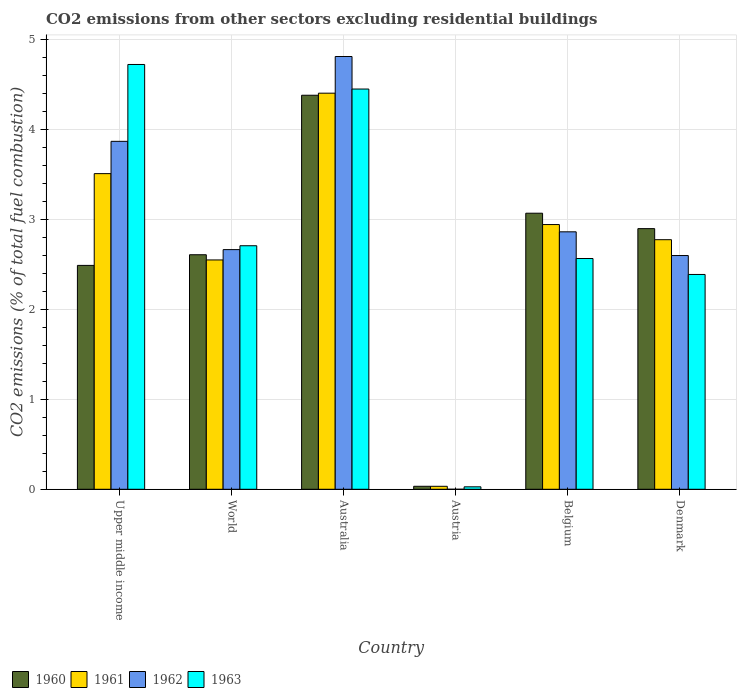How many different coloured bars are there?
Your answer should be very brief. 4. How many groups of bars are there?
Keep it short and to the point. 6. How many bars are there on the 1st tick from the left?
Keep it short and to the point. 4. In how many cases, is the number of bars for a given country not equal to the number of legend labels?
Offer a terse response. 1. What is the total CO2 emitted in 1963 in Austria?
Ensure brevity in your answer.  0.03. Across all countries, what is the maximum total CO2 emitted in 1961?
Make the answer very short. 4.41. Across all countries, what is the minimum total CO2 emitted in 1963?
Your response must be concise. 0.03. In which country was the total CO2 emitted in 1960 maximum?
Make the answer very short. Australia. What is the total total CO2 emitted in 1962 in the graph?
Make the answer very short. 16.82. What is the difference between the total CO2 emitted in 1961 in Belgium and that in World?
Offer a terse response. 0.39. What is the difference between the total CO2 emitted in 1962 in Australia and the total CO2 emitted in 1961 in Upper middle income?
Give a very brief answer. 1.3. What is the average total CO2 emitted in 1963 per country?
Your answer should be very brief. 2.81. What is the difference between the total CO2 emitted of/in 1961 and total CO2 emitted of/in 1962 in Upper middle income?
Your answer should be very brief. -0.36. In how many countries, is the total CO2 emitted in 1960 greater than 4.4?
Your answer should be very brief. 0. What is the ratio of the total CO2 emitted in 1963 in Australia to that in Belgium?
Offer a very short reply. 1.73. Is the difference between the total CO2 emitted in 1961 in Belgium and Denmark greater than the difference between the total CO2 emitted in 1962 in Belgium and Denmark?
Offer a very short reply. No. What is the difference between the highest and the second highest total CO2 emitted in 1961?
Your answer should be very brief. -0.57. What is the difference between the highest and the lowest total CO2 emitted in 1962?
Make the answer very short. 4.82. Is it the case that in every country, the sum of the total CO2 emitted in 1960 and total CO2 emitted in 1962 is greater than the total CO2 emitted in 1963?
Give a very brief answer. Yes. Does the graph contain any zero values?
Keep it short and to the point. Yes. Does the graph contain grids?
Your answer should be very brief. Yes. How many legend labels are there?
Provide a succinct answer. 4. How are the legend labels stacked?
Your response must be concise. Horizontal. What is the title of the graph?
Provide a short and direct response. CO2 emissions from other sectors excluding residential buildings. Does "1992" appear as one of the legend labels in the graph?
Your answer should be very brief. No. What is the label or title of the Y-axis?
Keep it short and to the point. CO2 emissions (% of total fuel combustion). What is the CO2 emissions (% of total fuel combustion) of 1960 in Upper middle income?
Give a very brief answer. 2.49. What is the CO2 emissions (% of total fuel combustion) in 1961 in Upper middle income?
Offer a very short reply. 3.51. What is the CO2 emissions (% of total fuel combustion) in 1962 in Upper middle income?
Ensure brevity in your answer.  3.87. What is the CO2 emissions (% of total fuel combustion) in 1963 in Upper middle income?
Offer a terse response. 4.73. What is the CO2 emissions (% of total fuel combustion) in 1960 in World?
Offer a terse response. 2.61. What is the CO2 emissions (% of total fuel combustion) in 1961 in World?
Offer a very short reply. 2.55. What is the CO2 emissions (% of total fuel combustion) in 1962 in World?
Offer a very short reply. 2.67. What is the CO2 emissions (% of total fuel combustion) in 1963 in World?
Provide a short and direct response. 2.71. What is the CO2 emissions (% of total fuel combustion) of 1960 in Australia?
Provide a short and direct response. 4.38. What is the CO2 emissions (% of total fuel combustion) of 1961 in Australia?
Ensure brevity in your answer.  4.41. What is the CO2 emissions (% of total fuel combustion) of 1962 in Australia?
Offer a very short reply. 4.82. What is the CO2 emissions (% of total fuel combustion) of 1963 in Australia?
Make the answer very short. 4.45. What is the CO2 emissions (% of total fuel combustion) in 1960 in Austria?
Offer a terse response. 0.03. What is the CO2 emissions (% of total fuel combustion) of 1961 in Austria?
Ensure brevity in your answer.  0.03. What is the CO2 emissions (% of total fuel combustion) of 1962 in Austria?
Keep it short and to the point. 0. What is the CO2 emissions (% of total fuel combustion) of 1963 in Austria?
Make the answer very short. 0.03. What is the CO2 emissions (% of total fuel combustion) of 1960 in Belgium?
Your answer should be very brief. 3.07. What is the CO2 emissions (% of total fuel combustion) in 1961 in Belgium?
Make the answer very short. 2.95. What is the CO2 emissions (% of total fuel combustion) in 1962 in Belgium?
Provide a succinct answer. 2.86. What is the CO2 emissions (% of total fuel combustion) of 1963 in Belgium?
Your answer should be compact. 2.57. What is the CO2 emissions (% of total fuel combustion) of 1960 in Denmark?
Provide a short and direct response. 2.9. What is the CO2 emissions (% of total fuel combustion) of 1961 in Denmark?
Ensure brevity in your answer.  2.78. What is the CO2 emissions (% of total fuel combustion) of 1962 in Denmark?
Provide a succinct answer. 2.6. What is the CO2 emissions (% of total fuel combustion) in 1963 in Denmark?
Ensure brevity in your answer.  2.39. Across all countries, what is the maximum CO2 emissions (% of total fuel combustion) of 1960?
Offer a very short reply. 4.38. Across all countries, what is the maximum CO2 emissions (% of total fuel combustion) of 1961?
Offer a very short reply. 4.41. Across all countries, what is the maximum CO2 emissions (% of total fuel combustion) in 1962?
Keep it short and to the point. 4.82. Across all countries, what is the maximum CO2 emissions (% of total fuel combustion) in 1963?
Give a very brief answer. 4.73. Across all countries, what is the minimum CO2 emissions (% of total fuel combustion) in 1960?
Offer a terse response. 0.03. Across all countries, what is the minimum CO2 emissions (% of total fuel combustion) of 1961?
Provide a succinct answer. 0.03. Across all countries, what is the minimum CO2 emissions (% of total fuel combustion) of 1963?
Make the answer very short. 0.03. What is the total CO2 emissions (% of total fuel combustion) of 1960 in the graph?
Provide a succinct answer. 15.49. What is the total CO2 emissions (% of total fuel combustion) in 1961 in the graph?
Your answer should be very brief. 16.23. What is the total CO2 emissions (% of total fuel combustion) of 1962 in the graph?
Offer a very short reply. 16.82. What is the total CO2 emissions (% of total fuel combustion) in 1963 in the graph?
Provide a succinct answer. 16.87. What is the difference between the CO2 emissions (% of total fuel combustion) of 1960 in Upper middle income and that in World?
Your answer should be compact. -0.12. What is the difference between the CO2 emissions (% of total fuel combustion) in 1961 in Upper middle income and that in World?
Ensure brevity in your answer.  0.96. What is the difference between the CO2 emissions (% of total fuel combustion) in 1962 in Upper middle income and that in World?
Your answer should be compact. 1.2. What is the difference between the CO2 emissions (% of total fuel combustion) in 1963 in Upper middle income and that in World?
Offer a terse response. 2.02. What is the difference between the CO2 emissions (% of total fuel combustion) of 1960 in Upper middle income and that in Australia?
Give a very brief answer. -1.89. What is the difference between the CO2 emissions (% of total fuel combustion) of 1961 in Upper middle income and that in Australia?
Provide a succinct answer. -0.9. What is the difference between the CO2 emissions (% of total fuel combustion) in 1962 in Upper middle income and that in Australia?
Offer a terse response. -0.94. What is the difference between the CO2 emissions (% of total fuel combustion) of 1963 in Upper middle income and that in Australia?
Provide a short and direct response. 0.27. What is the difference between the CO2 emissions (% of total fuel combustion) in 1960 in Upper middle income and that in Austria?
Your answer should be compact. 2.46. What is the difference between the CO2 emissions (% of total fuel combustion) in 1961 in Upper middle income and that in Austria?
Keep it short and to the point. 3.48. What is the difference between the CO2 emissions (% of total fuel combustion) in 1963 in Upper middle income and that in Austria?
Your response must be concise. 4.7. What is the difference between the CO2 emissions (% of total fuel combustion) in 1960 in Upper middle income and that in Belgium?
Your answer should be very brief. -0.58. What is the difference between the CO2 emissions (% of total fuel combustion) of 1961 in Upper middle income and that in Belgium?
Give a very brief answer. 0.57. What is the difference between the CO2 emissions (% of total fuel combustion) of 1962 in Upper middle income and that in Belgium?
Ensure brevity in your answer.  1.01. What is the difference between the CO2 emissions (% of total fuel combustion) of 1963 in Upper middle income and that in Belgium?
Provide a succinct answer. 2.16. What is the difference between the CO2 emissions (% of total fuel combustion) of 1960 in Upper middle income and that in Denmark?
Your response must be concise. -0.41. What is the difference between the CO2 emissions (% of total fuel combustion) in 1961 in Upper middle income and that in Denmark?
Keep it short and to the point. 0.74. What is the difference between the CO2 emissions (% of total fuel combustion) of 1962 in Upper middle income and that in Denmark?
Your answer should be very brief. 1.27. What is the difference between the CO2 emissions (% of total fuel combustion) of 1963 in Upper middle income and that in Denmark?
Provide a short and direct response. 2.34. What is the difference between the CO2 emissions (% of total fuel combustion) in 1960 in World and that in Australia?
Your answer should be compact. -1.77. What is the difference between the CO2 emissions (% of total fuel combustion) in 1961 in World and that in Australia?
Offer a very short reply. -1.86. What is the difference between the CO2 emissions (% of total fuel combustion) of 1962 in World and that in Australia?
Offer a very short reply. -2.15. What is the difference between the CO2 emissions (% of total fuel combustion) in 1963 in World and that in Australia?
Give a very brief answer. -1.74. What is the difference between the CO2 emissions (% of total fuel combustion) in 1960 in World and that in Austria?
Provide a short and direct response. 2.58. What is the difference between the CO2 emissions (% of total fuel combustion) of 1961 in World and that in Austria?
Make the answer very short. 2.52. What is the difference between the CO2 emissions (% of total fuel combustion) of 1963 in World and that in Austria?
Ensure brevity in your answer.  2.68. What is the difference between the CO2 emissions (% of total fuel combustion) of 1960 in World and that in Belgium?
Offer a terse response. -0.46. What is the difference between the CO2 emissions (% of total fuel combustion) of 1961 in World and that in Belgium?
Offer a terse response. -0.39. What is the difference between the CO2 emissions (% of total fuel combustion) of 1962 in World and that in Belgium?
Offer a very short reply. -0.2. What is the difference between the CO2 emissions (% of total fuel combustion) in 1963 in World and that in Belgium?
Provide a short and direct response. 0.14. What is the difference between the CO2 emissions (% of total fuel combustion) of 1960 in World and that in Denmark?
Your answer should be compact. -0.29. What is the difference between the CO2 emissions (% of total fuel combustion) in 1961 in World and that in Denmark?
Keep it short and to the point. -0.23. What is the difference between the CO2 emissions (% of total fuel combustion) of 1962 in World and that in Denmark?
Give a very brief answer. 0.07. What is the difference between the CO2 emissions (% of total fuel combustion) of 1963 in World and that in Denmark?
Ensure brevity in your answer.  0.32. What is the difference between the CO2 emissions (% of total fuel combustion) of 1960 in Australia and that in Austria?
Make the answer very short. 4.35. What is the difference between the CO2 emissions (% of total fuel combustion) of 1961 in Australia and that in Austria?
Your answer should be very brief. 4.37. What is the difference between the CO2 emissions (% of total fuel combustion) in 1963 in Australia and that in Austria?
Give a very brief answer. 4.43. What is the difference between the CO2 emissions (% of total fuel combustion) in 1960 in Australia and that in Belgium?
Provide a short and direct response. 1.31. What is the difference between the CO2 emissions (% of total fuel combustion) in 1961 in Australia and that in Belgium?
Provide a short and direct response. 1.46. What is the difference between the CO2 emissions (% of total fuel combustion) of 1962 in Australia and that in Belgium?
Give a very brief answer. 1.95. What is the difference between the CO2 emissions (% of total fuel combustion) of 1963 in Australia and that in Belgium?
Ensure brevity in your answer.  1.89. What is the difference between the CO2 emissions (% of total fuel combustion) in 1960 in Australia and that in Denmark?
Your response must be concise. 1.48. What is the difference between the CO2 emissions (% of total fuel combustion) in 1961 in Australia and that in Denmark?
Offer a terse response. 1.63. What is the difference between the CO2 emissions (% of total fuel combustion) in 1962 in Australia and that in Denmark?
Offer a terse response. 2.21. What is the difference between the CO2 emissions (% of total fuel combustion) of 1963 in Australia and that in Denmark?
Provide a succinct answer. 2.06. What is the difference between the CO2 emissions (% of total fuel combustion) in 1960 in Austria and that in Belgium?
Provide a short and direct response. -3.04. What is the difference between the CO2 emissions (% of total fuel combustion) of 1961 in Austria and that in Belgium?
Offer a very short reply. -2.91. What is the difference between the CO2 emissions (% of total fuel combustion) in 1963 in Austria and that in Belgium?
Make the answer very short. -2.54. What is the difference between the CO2 emissions (% of total fuel combustion) of 1960 in Austria and that in Denmark?
Your answer should be compact. -2.87. What is the difference between the CO2 emissions (% of total fuel combustion) in 1961 in Austria and that in Denmark?
Your answer should be very brief. -2.74. What is the difference between the CO2 emissions (% of total fuel combustion) in 1963 in Austria and that in Denmark?
Give a very brief answer. -2.36. What is the difference between the CO2 emissions (% of total fuel combustion) of 1960 in Belgium and that in Denmark?
Your answer should be very brief. 0.17. What is the difference between the CO2 emissions (% of total fuel combustion) of 1961 in Belgium and that in Denmark?
Your response must be concise. 0.17. What is the difference between the CO2 emissions (% of total fuel combustion) in 1962 in Belgium and that in Denmark?
Your answer should be very brief. 0.26. What is the difference between the CO2 emissions (% of total fuel combustion) in 1963 in Belgium and that in Denmark?
Provide a short and direct response. 0.18. What is the difference between the CO2 emissions (% of total fuel combustion) in 1960 in Upper middle income and the CO2 emissions (% of total fuel combustion) in 1961 in World?
Your response must be concise. -0.06. What is the difference between the CO2 emissions (% of total fuel combustion) of 1960 in Upper middle income and the CO2 emissions (% of total fuel combustion) of 1962 in World?
Give a very brief answer. -0.18. What is the difference between the CO2 emissions (% of total fuel combustion) of 1960 in Upper middle income and the CO2 emissions (% of total fuel combustion) of 1963 in World?
Make the answer very short. -0.22. What is the difference between the CO2 emissions (% of total fuel combustion) in 1961 in Upper middle income and the CO2 emissions (% of total fuel combustion) in 1962 in World?
Make the answer very short. 0.85. What is the difference between the CO2 emissions (% of total fuel combustion) of 1961 in Upper middle income and the CO2 emissions (% of total fuel combustion) of 1963 in World?
Ensure brevity in your answer.  0.8. What is the difference between the CO2 emissions (% of total fuel combustion) of 1962 in Upper middle income and the CO2 emissions (% of total fuel combustion) of 1963 in World?
Ensure brevity in your answer.  1.16. What is the difference between the CO2 emissions (% of total fuel combustion) in 1960 in Upper middle income and the CO2 emissions (% of total fuel combustion) in 1961 in Australia?
Your answer should be very brief. -1.92. What is the difference between the CO2 emissions (% of total fuel combustion) in 1960 in Upper middle income and the CO2 emissions (% of total fuel combustion) in 1962 in Australia?
Ensure brevity in your answer.  -2.32. What is the difference between the CO2 emissions (% of total fuel combustion) in 1960 in Upper middle income and the CO2 emissions (% of total fuel combustion) in 1963 in Australia?
Provide a succinct answer. -1.96. What is the difference between the CO2 emissions (% of total fuel combustion) of 1961 in Upper middle income and the CO2 emissions (% of total fuel combustion) of 1962 in Australia?
Provide a short and direct response. -1.3. What is the difference between the CO2 emissions (% of total fuel combustion) in 1961 in Upper middle income and the CO2 emissions (% of total fuel combustion) in 1963 in Australia?
Offer a terse response. -0.94. What is the difference between the CO2 emissions (% of total fuel combustion) in 1962 in Upper middle income and the CO2 emissions (% of total fuel combustion) in 1963 in Australia?
Make the answer very short. -0.58. What is the difference between the CO2 emissions (% of total fuel combustion) of 1960 in Upper middle income and the CO2 emissions (% of total fuel combustion) of 1961 in Austria?
Provide a succinct answer. 2.46. What is the difference between the CO2 emissions (% of total fuel combustion) of 1960 in Upper middle income and the CO2 emissions (% of total fuel combustion) of 1963 in Austria?
Your answer should be compact. 2.46. What is the difference between the CO2 emissions (% of total fuel combustion) in 1961 in Upper middle income and the CO2 emissions (% of total fuel combustion) in 1963 in Austria?
Provide a short and direct response. 3.48. What is the difference between the CO2 emissions (% of total fuel combustion) in 1962 in Upper middle income and the CO2 emissions (% of total fuel combustion) in 1963 in Austria?
Your response must be concise. 3.84. What is the difference between the CO2 emissions (% of total fuel combustion) of 1960 in Upper middle income and the CO2 emissions (% of total fuel combustion) of 1961 in Belgium?
Keep it short and to the point. -0.45. What is the difference between the CO2 emissions (% of total fuel combustion) of 1960 in Upper middle income and the CO2 emissions (% of total fuel combustion) of 1962 in Belgium?
Your answer should be very brief. -0.37. What is the difference between the CO2 emissions (% of total fuel combustion) in 1960 in Upper middle income and the CO2 emissions (% of total fuel combustion) in 1963 in Belgium?
Ensure brevity in your answer.  -0.08. What is the difference between the CO2 emissions (% of total fuel combustion) in 1961 in Upper middle income and the CO2 emissions (% of total fuel combustion) in 1962 in Belgium?
Make the answer very short. 0.65. What is the difference between the CO2 emissions (% of total fuel combustion) of 1962 in Upper middle income and the CO2 emissions (% of total fuel combustion) of 1963 in Belgium?
Your answer should be compact. 1.3. What is the difference between the CO2 emissions (% of total fuel combustion) in 1960 in Upper middle income and the CO2 emissions (% of total fuel combustion) in 1961 in Denmark?
Your answer should be compact. -0.29. What is the difference between the CO2 emissions (% of total fuel combustion) in 1960 in Upper middle income and the CO2 emissions (% of total fuel combustion) in 1962 in Denmark?
Make the answer very short. -0.11. What is the difference between the CO2 emissions (% of total fuel combustion) of 1960 in Upper middle income and the CO2 emissions (% of total fuel combustion) of 1963 in Denmark?
Give a very brief answer. 0.1. What is the difference between the CO2 emissions (% of total fuel combustion) of 1961 in Upper middle income and the CO2 emissions (% of total fuel combustion) of 1962 in Denmark?
Offer a terse response. 0.91. What is the difference between the CO2 emissions (% of total fuel combustion) of 1961 in Upper middle income and the CO2 emissions (% of total fuel combustion) of 1963 in Denmark?
Give a very brief answer. 1.12. What is the difference between the CO2 emissions (% of total fuel combustion) in 1962 in Upper middle income and the CO2 emissions (% of total fuel combustion) in 1963 in Denmark?
Keep it short and to the point. 1.48. What is the difference between the CO2 emissions (% of total fuel combustion) in 1960 in World and the CO2 emissions (% of total fuel combustion) in 1961 in Australia?
Make the answer very short. -1.8. What is the difference between the CO2 emissions (% of total fuel combustion) in 1960 in World and the CO2 emissions (% of total fuel combustion) in 1962 in Australia?
Make the answer very short. -2.21. What is the difference between the CO2 emissions (% of total fuel combustion) in 1960 in World and the CO2 emissions (% of total fuel combustion) in 1963 in Australia?
Offer a very short reply. -1.84. What is the difference between the CO2 emissions (% of total fuel combustion) of 1961 in World and the CO2 emissions (% of total fuel combustion) of 1962 in Australia?
Make the answer very short. -2.26. What is the difference between the CO2 emissions (% of total fuel combustion) of 1961 in World and the CO2 emissions (% of total fuel combustion) of 1963 in Australia?
Give a very brief answer. -1.9. What is the difference between the CO2 emissions (% of total fuel combustion) in 1962 in World and the CO2 emissions (% of total fuel combustion) in 1963 in Australia?
Provide a short and direct response. -1.79. What is the difference between the CO2 emissions (% of total fuel combustion) of 1960 in World and the CO2 emissions (% of total fuel combustion) of 1961 in Austria?
Give a very brief answer. 2.58. What is the difference between the CO2 emissions (% of total fuel combustion) of 1960 in World and the CO2 emissions (% of total fuel combustion) of 1963 in Austria?
Offer a terse response. 2.58. What is the difference between the CO2 emissions (% of total fuel combustion) of 1961 in World and the CO2 emissions (% of total fuel combustion) of 1963 in Austria?
Provide a succinct answer. 2.52. What is the difference between the CO2 emissions (% of total fuel combustion) of 1962 in World and the CO2 emissions (% of total fuel combustion) of 1963 in Austria?
Make the answer very short. 2.64. What is the difference between the CO2 emissions (% of total fuel combustion) of 1960 in World and the CO2 emissions (% of total fuel combustion) of 1961 in Belgium?
Give a very brief answer. -0.34. What is the difference between the CO2 emissions (% of total fuel combustion) in 1960 in World and the CO2 emissions (% of total fuel combustion) in 1962 in Belgium?
Keep it short and to the point. -0.26. What is the difference between the CO2 emissions (% of total fuel combustion) in 1960 in World and the CO2 emissions (% of total fuel combustion) in 1963 in Belgium?
Provide a short and direct response. 0.04. What is the difference between the CO2 emissions (% of total fuel combustion) in 1961 in World and the CO2 emissions (% of total fuel combustion) in 1962 in Belgium?
Give a very brief answer. -0.31. What is the difference between the CO2 emissions (% of total fuel combustion) in 1961 in World and the CO2 emissions (% of total fuel combustion) in 1963 in Belgium?
Your response must be concise. -0.02. What is the difference between the CO2 emissions (% of total fuel combustion) in 1962 in World and the CO2 emissions (% of total fuel combustion) in 1963 in Belgium?
Provide a succinct answer. 0.1. What is the difference between the CO2 emissions (% of total fuel combustion) in 1960 in World and the CO2 emissions (% of total fuel combustion) in 1961 in Denmark?
Your answer should be compact. -0.17. What is the difference between the CO2 emissions (% of total fuel combustion) of 1960 in World and the CO2 emissions (% of total fuel combustion) of 1962 in Denmark?
Your answer should be very brief. 0.01. What is the difference between the CO2 emissions (% of total fuel combustion) in 1960 in World and the CO2 emissions (% of total fuel combustion) in 1963 in Denmark?
Your answer should be very brief. 0.22. What is the difference between the CO2 emissions (% of total fuel combustion) of 1961 in World and the CO2 emissions (% of total fuel combustion) of 1962 in Denmark?
Make the answer very short. -0.05. What is the difference between the CO2 emissions (% of total fuel combustion) in 1961 in World and the CO2 emissions (% of total fuel combustion) in 1963 in Denmark?
Your answer should be compact. 0.16. What is the difference between the CO2 emissions (% of total fuel combustion) of 1962 in World and the CO2 emissions (% of total fuel combustion) of 1963 in Denmark?
Your answer should be compact. 0.28. What is the difference between the CO2 emissions (% of total fuel combustion) of 1960 in Australia and the CO2 emissions (% of total fuel combustion) of 1961 in Austria?
Your response must be concise. 4.35. What is the difference between the CO2 emissions (% of total fuel combustion) in 1960 in Australia and the CO2 emissions (% of total fuel combustion) in 1963 in Austria?
Offer a very short reply. 4.36. What is the difference between the CO2 emissions (% of total fuel combustion) of 1961 in Australia and the CO2 emissions (% of total fuel combustion) of 1963 in Austria?
Make the answer very short. 4.38. What is the difference between the CO2 emissions (% of total fuel combustion) in 1962 in Australia and the CO2 emissions (% of total fuel combustion) in 1963 in Austria?
Offer a terse response. 4.79. What is the difference between the CO2 emissions (% of total fuel combustion) in 1960 in Australia and the CO2 emissions (% of total fuel combustion) in 1961 in Belgium?
Give a very brief answer. 1.44. What is the difference between the CO2 emissions (% of total fuel combustion) of 1960 in Australia and the CO2 emissions (% of total fuel combustion) of 1962 in Belgium?
Your response must be concise. 1.52. What is the difference between the CO2 emissions (% of total fuel combustion) of 1960 in Australia and the CO2 emissions (% of total fuel combustion) of 1963 in Belgium?
Keep it short and to the point. 1.82. What is the difference between the CO2 emissions (% of total fuel combustion) in 1961 in Australia and the CO2 emissions (% of total fuel combustion) in 1962 in Belgium?
Make the answer very short. 1.54. What is the difference between the CO2 emissions (% of total fuel combustion) of 1961 in Australia and the CO2 emissions (% of total fuel combustion) of 1963 in Belgium?
Make the answer very short. 1.84. What is the difference between the CO2 emissions (% of total fuel combustion) in 1962 in Australia and the CO2 emissions (% of total fuel combustion) in 1963 in Belgium?
Provide a succinct answer. 2.25. What is the difference between the CO2 emissions (% of total fuel combustion) of 1960 in Australia and the CO2 emissions (% of total fuel combustion) of 1961 in Denmark?
Your answer should be compact. 1.61. What is the difference between the CO2 emissions (% of total fuel combustion) in 1960 in Australia and the CO2 emissions (% of total fuel combustion) in 1962 in Denmark?
Give a very brief answer. 1.78. What is the difference between the CO2 emissions (% of total fuel combustion) of 1960 in Australia and the CO2 emissions (% of total fuel combustion) of 1963 in Denmark?
Provide a short and direct response. 1.99. What is the difference between the CO2 emissions (% of total fuel combustion) of 1961 in Australia and the CO2 emissions (% of total fuel combustion) of 1962 in Denmark?
Ensure brevity in your answer.  1.81. What is the difference between the CO2 emissions (% of total fuel combustion) in 1961 in Australia and the CO2 emissions (% of total fuel combustion) in 1963 in Denmark?
Make the answer very short. 2.02. What is the difference between the CO2 emissions (% of total fuel combustion) in 1962 in Australia and the CO2 emissions (% of total fuel combustion) in 1963 in Denmark?
Keep it short and to the point. 2.42. What is the difference between the CO2 emissions (% of total fuel combustion) of 1960 in Austria and the CO2 emissions (% of total fuel combustion) of 1961 in Belgium?
Your response must be concise. -2.91. What is the difference between the CO2 emissions (% of total fuel combustion) in 1960 in Austria and the CO2 emissions (% of total fuel combustion) in 1962 in Belgium?
Offer a very short reply. -2.83. What is the difference between the CO2 emissions (% of total fuel combustion) in 1960 in Austria and the CO2 emissions (% of total fuel combustion) in 1963 in Belgium?
Keep it short and to the point. -2.53. What is the difference between the CO2 emissions (% of total fuel combustion) in 1961 in Austria and the CO2 emissions (% of total fuel combustion) in 1962 in Belgium?
Keep it short and to the point. -2.83. What is the difference between the CO2 emissions (% of total fuel combustion) of 1961 in Austria and the CO2 emissions (% of total fuel combustion) of 1963 in Belgium?
Provide a succinct answer. -2.53. What is the difference between the CO2 emissions (% of total fuel combustion) of 1960 in Austria and the CO2 emissions (% of total fuel combustion) of 1961 in Denmark?
Your response must be concise. -2.74. What is the difference between the CO2 emissions (% of total fuel combustion) in 1960 in Austria and the CO2 emissions (% of total fuel combustion) in 1962 in Denmark?
Your answer should be compact. -2.57. What is the difference between the CO2 emissions (% of total fuel combustion) in 1960 in Austria and the CO2 emissions (% of total fuel combustion) in 1963 in Denmark?
Your answer should be very brief. -2.36. What is the difference between the CO2 emissions (% of total fuel combustion) in 1961 in Austria and the CO2 emissions (% of total fuel combustion) in 1962 in Denmark?
Provide a succinct answer. -2.57. What is the difference between the CO2 emissions (% of total fuel combustion) in 1961 in Austria and the CO2 emissions (% of total fuel combustion) in 1963 in Denmark?
Provide a succinct answer. -2.36. What is the difference between the CO2 emissions (% of total fuel combustion) in 1960 in Belgium and the CO2 emissions (% of total fuel combustion) in 1961 in Denmark?
Offer a terse response. 0.29. What is the difference between the CO2 emissions (% of total fuel combustion) in 1960 in Belgium and the CO2 emissions (% of total fuel combustion) in 1962 in Denmark?
Make the answer very short. 0.47. What is the difference between the CO2 emissions (% of total fuel combustion) in 1960 in Belgium and the CO2 emissions (% of total fuel combustion) in 1963 in Denmark?
Offer a terse response. 0.68. What is the difference between the CO2 emissions (% of total fuel combustion) of 1961 in Belgium and the CO2 emissions (% of total fuel combustion) of 1962 in Denmark?
Keep it short and to the point. 0.34. What is the difference between the CO2 emissions (% of total fuel combustion) in 1961 in Belgium and the CO2 emissions (% of total fuel combustion) in 1963 in Denmark?
Provide a succinct answer. 0.56. What is the difference between the CO2 emissions (% of total fuel combustion) in 1962 in Belgium and the CO2 emissions (% of total fuel combustion) in 1963 in Denmark?
Keep it short and to the point. 0.47. What is the average CO2 emissions (% of total fuel combustion) in 1960 per country?
Make the answer very short. 2.58. What is the average CO2 emissions (% of total fuel combustion) of 1961 per country?
Provide a short and direct response. 2.7. What is the average CO2 emissions (% of total fuel combustion) in 1962 per country?
Provide a succinct answer. 2.8. What is the average CO2 emissions (% of total fuel combustion) in 1963 per country?
Offer a very short reply. 2.81. What is the difference between the CO2 emissions (% of total fuel combustion) of 1960 and CO2 emissions (% of total fuel combustion) of 1961 in Upper middle income?
Provide a succinct answer. -1.02. What is the difference between the CO2 emissions (% of total fuel combustion) in 1960 and CO2 emissions (% of total fuel combustion) in 1962 in Upper middle income?
Your response must be concise. -1.38. What is the difference between the CO2 emissions (% of total fuel combustion) in 1960 and CO2 emissions (% of total fuel combustion) in 1963 in Upper middle income?
Your answer should be very brief. -2.24. What is the difference between the CO2 emissions (% of total fuel combustion) of 1961 and CO2 emissions (% of total fuel combustion) of 1962 in Upper middle income?
Offer a terse response. -0.36. What is the difference between the CO2 emissions (% of total fuel combustion) of 1961 and CO2 emissions (% of total fuel combustion) of 1963 in Upper middle income?
Ensure brevity in your answer.  -1.21. What is the difference between the CO2 emissions (% of total fuel combustion) of 1962 and CO2 emissions (% of total fuel combustion) of 1963 in Upper middle income?
Keep it short and to the point. -0.85. What is the difference between the CO2 emissions (% of total fuel combustion) of 1960 and CO2 emissions (% of total fuel combustion) of 1961 in World?
Offer a terse response. 0.06. What is the difference between the CO2 emissions (% of total fuel combustion) of 1960 and CO2 emissions (% of total fuel combustion) of 1962 in World?
Your response must be concise. -0.06. What is the difference between the CO2 emissions (% of total fuel combustion) in 1960 and CO2 emissions (% of total fuel combustion) in 1963 in World?
Your answer should be very brief. -0.1. What is the difference between the CO2 emissions (% of total fuel combustion) of 1961 and CO2 emissions (% of total fuel combustion) of 1962 in World?
Your answer should be very brief. -0.12. What is the difference between the CO2 emissions (% of total fuel combustion) of 1961 and CO2 emissions (% of total fuel combustion) of 1963 in World?
Provide a succinct answer. -0.16. What is the difference between the CO2 emissions (% of total fuel combustion) in 1962 and CO2 emissions (% of total fuel combustion) in 1963 in World?
Offer a terse response. -0.04. What is the difference between the CO2 emissions (% of total fuel combustion) in 1960 and CO2 emissions (% of total fuel combustion) in 1961 in Australia?
Give a very brief answer. -0.02. What is the difference between the CO2 emissions (% of total fuel combustion) of 1960 and CO2 emissions (% of total fuel combustion) of 1962 in Australia?
Your answer should be compact. -0.43. What is the difference between the CO2 emissions (% of total fuel combustion) in 1960 and CO2 emissions (% of total fuel combustion) in 1963 in Australia?
Ensure brevity in your answer.  -0.07. What is the difference between the CO2 emissions (% of total fuel combustion) of 1961 and CO2 emissions (% of total fuel combustion) of 1962 in Australia?
Your answer should be very brief. -0.41. What is the difference between the CO2 emissions (% of total fuel combustion) in 1961 and CO2 emissions (% of total fuel combustion) in 1963 in Australia?
Keep it short and to the point. -0.05. What is the difference between the CO2 emissions (% of total fuel combustion) of 1962 and CO2 emissions (% of total fuel combustion) of 1963 in Australia?
Make the answer very short. 0.36. What is the difference between the CO2 emissions (% of total fuel combustion) in 1960 and CO2 emissions (% of total fuel combustion) in 1963 in Austria?
Your answer should be compact. 0.01. What is the difference between the CO2 emissions (% of total fuel combustion) of 1961 and CO2 emissions (% of total fuel combustion) of 1963 in Austria?
Make the answer very short. 0.01. What is the difference between the CO2 emissions (% of total fuel combustion) of 1960 and CO2 emissions (% of total fuel combustion) of 1961 in Belgium?
Provide a short and direct response. 0.13. What is the difference between the CO2 emissions (% of total fuel combustion) in 1960 and CO2 emissions (% of total fuel combustion) in 1962 in Belgium?
Ensure brevity in your answer.  0.21. What is the difference between the CO2 emissions (% of total fuel combustion) in 1960 and CO2 emissions (% of total fuel combustion) in 1963 in Belgium?
Your answer should be very brief. 0.5. What is the difference between the CO2 emissions (% of total fuel combustion) of 1961 and CO2 emissions (% of total fuel combustion) of 1962 in Belgium?
Offer a terse response. 0.08. What is the difference between the CO2 emissions (% of total fuel combustion) of 1961 and CO2 emissions (% of total fuel combustion) of 1963 in Belgium?
Keep it short and to the point. 0.38. What is the difference between the CO2 emissions (% of total fuel combustion) in 1962 and CO2 emissions (% of total fuel combustion) in 1963 in Belgium?
Provide a succinct answer. 0.3. What is the difference between the CO2 emissions (% of total fuel combustion) in 1960 and CO2 emissions (% of total fuel combustion) in 1961 in Denmark?
Provide a succinct answer. 0.12. What is the difference between the CO2 emissions (% of total fuel combustion) of 1960 and CO2 emissions (% of total fuel combustion) of 1962 in Denmark?
Give a very brief answer. 0.3. What is the difference between the CO2 emissions (% of total fuel combustion) of 1960 and CO2 emissions (% of total fuel combustion) of 1963 in Denmark?
Ensure brevity in your answer.  0.51. What is the difference between the CO2 emissions (% of total fuel combustion) in 1961 and CO2 emissions (% of total fuel combustion) in 1962 in Denmark?
Offer a terse response. 0.18. What is the difference between the CO2 emissions (% of total fuel combustion) in 1961 and CO2 emissions (% of total fuel combustion) in 1963 in Denmark?
Offer a very short reply. 0.39. What is the difference between the CO2 emissions (% of total fuel combustion) of 1962 and CO2 emissions (% of total fuel combustion) of 1963 in Denmark?
Provide a short and direct response. 0.21. What is the ratio of the CO2 emissions (% of total fuel combustion) in 1960 in Upper middle income to that in World?
Give a very brief answer. 0.95. What is the ratio of the CO2 emissions (% of total fuel combustion) of 1961 in Upper middle income to that in World?
Keep it short and to the point. 1.38. What is the ratio of the CO2 emissions (% of total fuel combustion) in 1962 in Upper middle income to that in World?
Your answer should be very brief. 1.45. What is the ratio of the CO2 emissions (% of total fuel combustion) in 1963 in Upper middle income to that in World?
Offer a very short reply. 1.74. What is the ratio of the CO2 emissions (% of total fuel combustion) in 1960 in Upper middle income to that in Australia?
Provide a short and direct response. 0.57. What is the ratio of the CO2 emissions (% of total fuel combustion) of 1961 in Upper middle income to that in Australia?
Ensure brevity in your answer.  0.8. What is the ratio of the CO2 emissions (% of total fuel combustion) of 1962 in Upper middle income to that in Australia?
Offer a very short reply. 0.8. What is the ratio of the CO2 emissions (% of total fuel combustion) in 1963 in Upper middle income to that in Australia?
Your answer should be very brief. 1.06. What is the ratio of the CO2 emissions (% of total fuel combustion) in 1960 in Upper middle income to that in Austria?
Provide a succinct answer. 74.9. What is the ratio of the CO2 emissions (% of total fuel combustion) of 1961 in Upper middle income to that in Austria?
Your response must be concise. 106.48. What is the ratio of the CO2 emissions (% of total fuel combustion) in 1963 in Upper middle income to that in Austria?
Make the answer very short. 173.08. What is the ratio of the CO2 emissions (% of total fuel combustion) in 1960 in Upper middle income to that in Belgium?
Your response must be concise. 0.81. What is the ratio of the CO2 emissions (% of total fuel combustion) of 1961 in Upper middle income to that in Belgium?
Your response must be concise. 1.19. What is the ratio of the CO2 emissions (% of total fuel combustion) of 1962 in Upper middle income to that in Belgium?
Provide a short and direct response. 1.35. What is the ratio of the CO2 emissions (% of total fuel combustion) in 1963 in Upper middle income to that in Belgium?
Keep it short and to the point. 1.84. What is the ratio of the CO2 emissions (% of total fuel combustion) of 1960 in Upper middle income to that in Denmark?
Offer a very short reply. 0.86. What is the ratio of the CO2 emissions (% of total fuel combustion) of 1961 in Upper middle income to that in Denmark?
Your answer should be very brief. 1.26. What is the ratio of the CO2 emissions (% of total fuel combustion) in 1962 in Upper middle income to that in Denmark?
Your answer should be very brief. 1.49. What is the ratio of the CO2 emissions (% of total fuel combustion) in 1963 in Upper middle income to that in Denmark?
Provide a short and direct response. 1.98. What is the ratio of the CO2 emissions (% of total fuel combustion) of 1960 in World to that in Australia?
Your answer should be very brief. 0.6. What is the ratio of the CO2 emissions (% of total fuel combustion) in 1961 in World to that in Australia?
Keep it short and to the point. 0.58. What is the ratio of the CO2 emissions (% of total fuel combustion) in 1962 in World to that in Australia?
Your answer should be very brief. 0.55. What is the ratio of the CO2 emissions (% of total fuel combustion) of 1963 in World to that in Australia?
Ensure brevity in your answer.  0.61. What is the ratio of the CO2 emissions (% of total fuel combustion) in 1960 in World to that in Austria?
Offer a very short reply. 78.47. What is the ratio of the CO2 emissions (% of total fuel combustion) of 1961 in World to that in Austria?
Provide a short and direct response. 77.37. What is the ratio of the CO2 emissions (% of total fuel combustion) of 1963 in World to that in Austria?
Keep it short and to the point. 99.22. What is the ratio of the CO2 emissions (% of total fuel combustion) in 1960 in World to that in Belgium?
Provide a succinct answer. 0.85. What is the ratio of the CO2 emissions (% of total fuel combustion) in 1961 in World to that in Belgium?
Offer a terse response. 0.87. What is the ratio of the CO2 emissions (% of total fuel combustion) of 1962 in World to that in Belgium?
Your answer should be compact. 0.93. What is the ratio of the CO2 emissions (% of total fuel combustion) of 1963 in World to that in Belgium?
Ensure brevity in your answer.  1.06. What is the ratio of the CO2 emissions (% of total fuel combustion) in 1960 in World to that in Denmark?
Your answer should be compact. 0.9. What is the ratio of the CO2 emissions (% of total fuel combustion) in 1961 in World to that in Denmark?
Provide a short and direct response. 0.92. What is the ratio of the CO2 emissions (% of total fuel combustion) of 1962 in World to that in Denmark?
Offer a very short reply. 1.03. What is the ratio of the CO2 emissions (% of total fuel combustion) of 1963 in World to that in Denmark?
Your response must be concise. 1.13. What is the ratio of the CO2 emissions (% of total fuel combustion) of 1960 in Australia to that in Austria?
Give a very brief answer. 131.83. What is the ratio of the CO2 emissions (% of total fuel combustion) of 1961 in Australia to that in Austria?
Provide a short and direct response. 133.62. What is the ratio of the CO2 emissions (% of total fuel combustion) in 1963 in Australia to that in Austria?
Ensure brevity in your answer.  163.07. What is the ratio of the CO2 emissions (% of total fuel combustion) in 1960 in Australia to that in Belgium?
Give a very brief answer. 1.43. What is the ratio of the CO2 emissions (% of total fuel combustion) in 1961 in Australia to that in Belgium?
Your response must be concise. 1.5. What is the ratio of the CO2 emissions (% of total fuel combustion) of 1962 in Australia to that in Belgium?
Provide a succinct answer. 1.68. What is the ratio of the CO2 emissions (% of total fuel combustion) in 1963 in Australia to that in Belgium?
Provide a succinct answer. 1.73. What is the ratio of the CO2 emissions (% of total fuel combustion) in 1960 in Australia to that in Denmark?
Keep it short and to the point. 1.51. What is the ratio of the CO2 emissions (% of total fuel combustion) in 1961 in Australia to that in Denmark?
Keep it short and to the point. 1.59. What is the ratio of the CO2 emissions (% of total fuel combustion) in 1962 in Australia to that in Denmark?
Your response must be concise. 1.85. What is the ratio of the CO2 emissions (% of total fuel combustion) of 1963 in Australia to that in Denmark?
Offer a very short reply. 1.86. What is the ratio of the CO2 emissions (% of total fuel combustion) of 1960 in Austria to that in Belgium?
Make the answer very short. 0.01. What is the ratio of the CO2 emissions (% of total fuel combustion) of 1961 in Austria to that in Belgium?
Your answer should be compact. 0.01. What is the ratio of the CO2 emissions (% of total fuel combustion) in 1963 in Austria to that in Belgium?
Your answer should be very brief. 0.01. What is the ratio of the CO2 emissions (% of total fuel combustion) of 1960 in Austria to that in Denmark?
Your response must be concise. 0.01. What is the ratio of the CO2 emissions (% of total fuel combustion) in 1961 in Austria to that in Denmark?
Ensure brevity in your answer.  0.01. What is the ratio of the CO2 emissions (% of total fuel combustion) in 1963 in Austria to that in Denmark?
Offer a very short reply. 0.01. What is the ratio of the CO2 emissions (% of total fuel combustion) in 1960 in Belgium to that in Denmark?
Offer a terse response. 1.06. What is the ratio of the CO2 emissions (% of total fuel combustion) in 1961 in Belgium to that in Denmark?
Provide a succinct answer. 1.06. What is the ratio of the CO2 emissions (% of total fuel combustion) of 1962 in Belgium to that in Denmark?
Your answer should be very brief. 1.1. What is the ratio of the CO2 emissions (% of total fuel combustion) in 1963 in Belgium to that in Denmark?
Make the answer very short. 1.07. What is the difference between the highest and the second highest CO2 emissions (% of total fuel combustion) in 1960?
Offer a very short reply. 1.31. What is the difference between the highest and the second highest CO2 emissions (% of total fuel combustion) of 1961?
Provide a succinct answer. 0.9. What is the difference between the highest and the second highest CO2 emissions (% of total fuel combustion) in 1962?
Provide a succinct answer. 0.94. What is the difference between the highest and the second highest CO2 emissions (% of total fuel combustion) of 1963?
Provide a short and direct response. 0.27. What is the difference between the highest and the lowest CO2 emissions (% of total fuel combustion) of 1960?
Your response must be concise. 4.35. What is the difference between the highest and the lowest CO2 emissions (% of total fuel combustion) in 1961?
Offer a terse response. 4.37. What is the difference between the highest and the lowest CO2 emissions (% of total fuel combustion) of 1962?
Make the answer very short. 4.82. What is the difference between the highest and the lowest CO2 emissions (% of total fuel combustion) of 1963?
Ensure brevity in your answer.  4.7. 